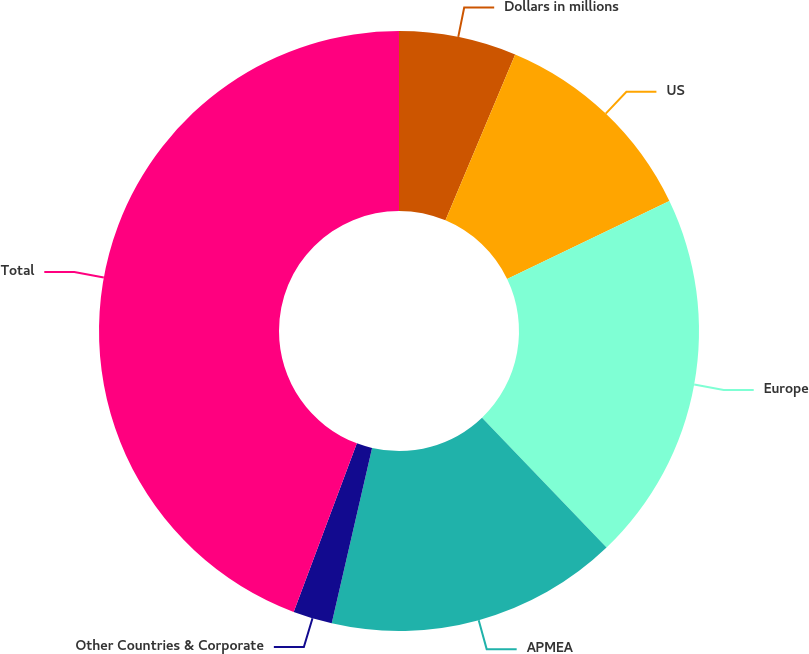<chart> <loc_0><loc_0><loc_500><loc_500><pie_chart><fcel>Dollars in millions<fcel>US<fcel>Europe<fcel>APMEA<fcel>Other Countries & Corporate<fcel>Total<nl><fcel>6.33%<fcel>11.54%<fcel>19.97%<fcel>15.76%<fcel>2.11%<fcel>44.29%<nl></chart> 